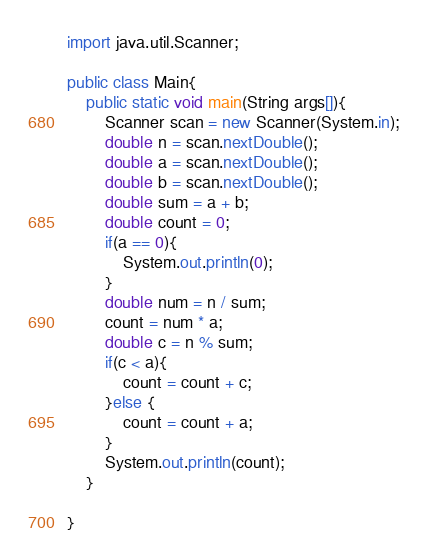<code> <loc_0><loc_0><loc_500><loc_500><_Java_>import java.util.Scanner;

public class Main{
    public static void main(String args[]){
        Scanner scan = new Scanner(System.in);
        double n = scan.nextDouble();
        double a = scan.nextDouble();
        double b = scan.nextDouble();
        double sum = a + b;
        double count = 0;
        if(a == 0){
            System.out.println(0);
        }
        double num = n / sum;
        count = num * a;
        double c = n % sum;
        if(c < a){
            count = count + c;
        }else {
            count = count + a;
        }
        System.out.println(count);
    }

}</code> 